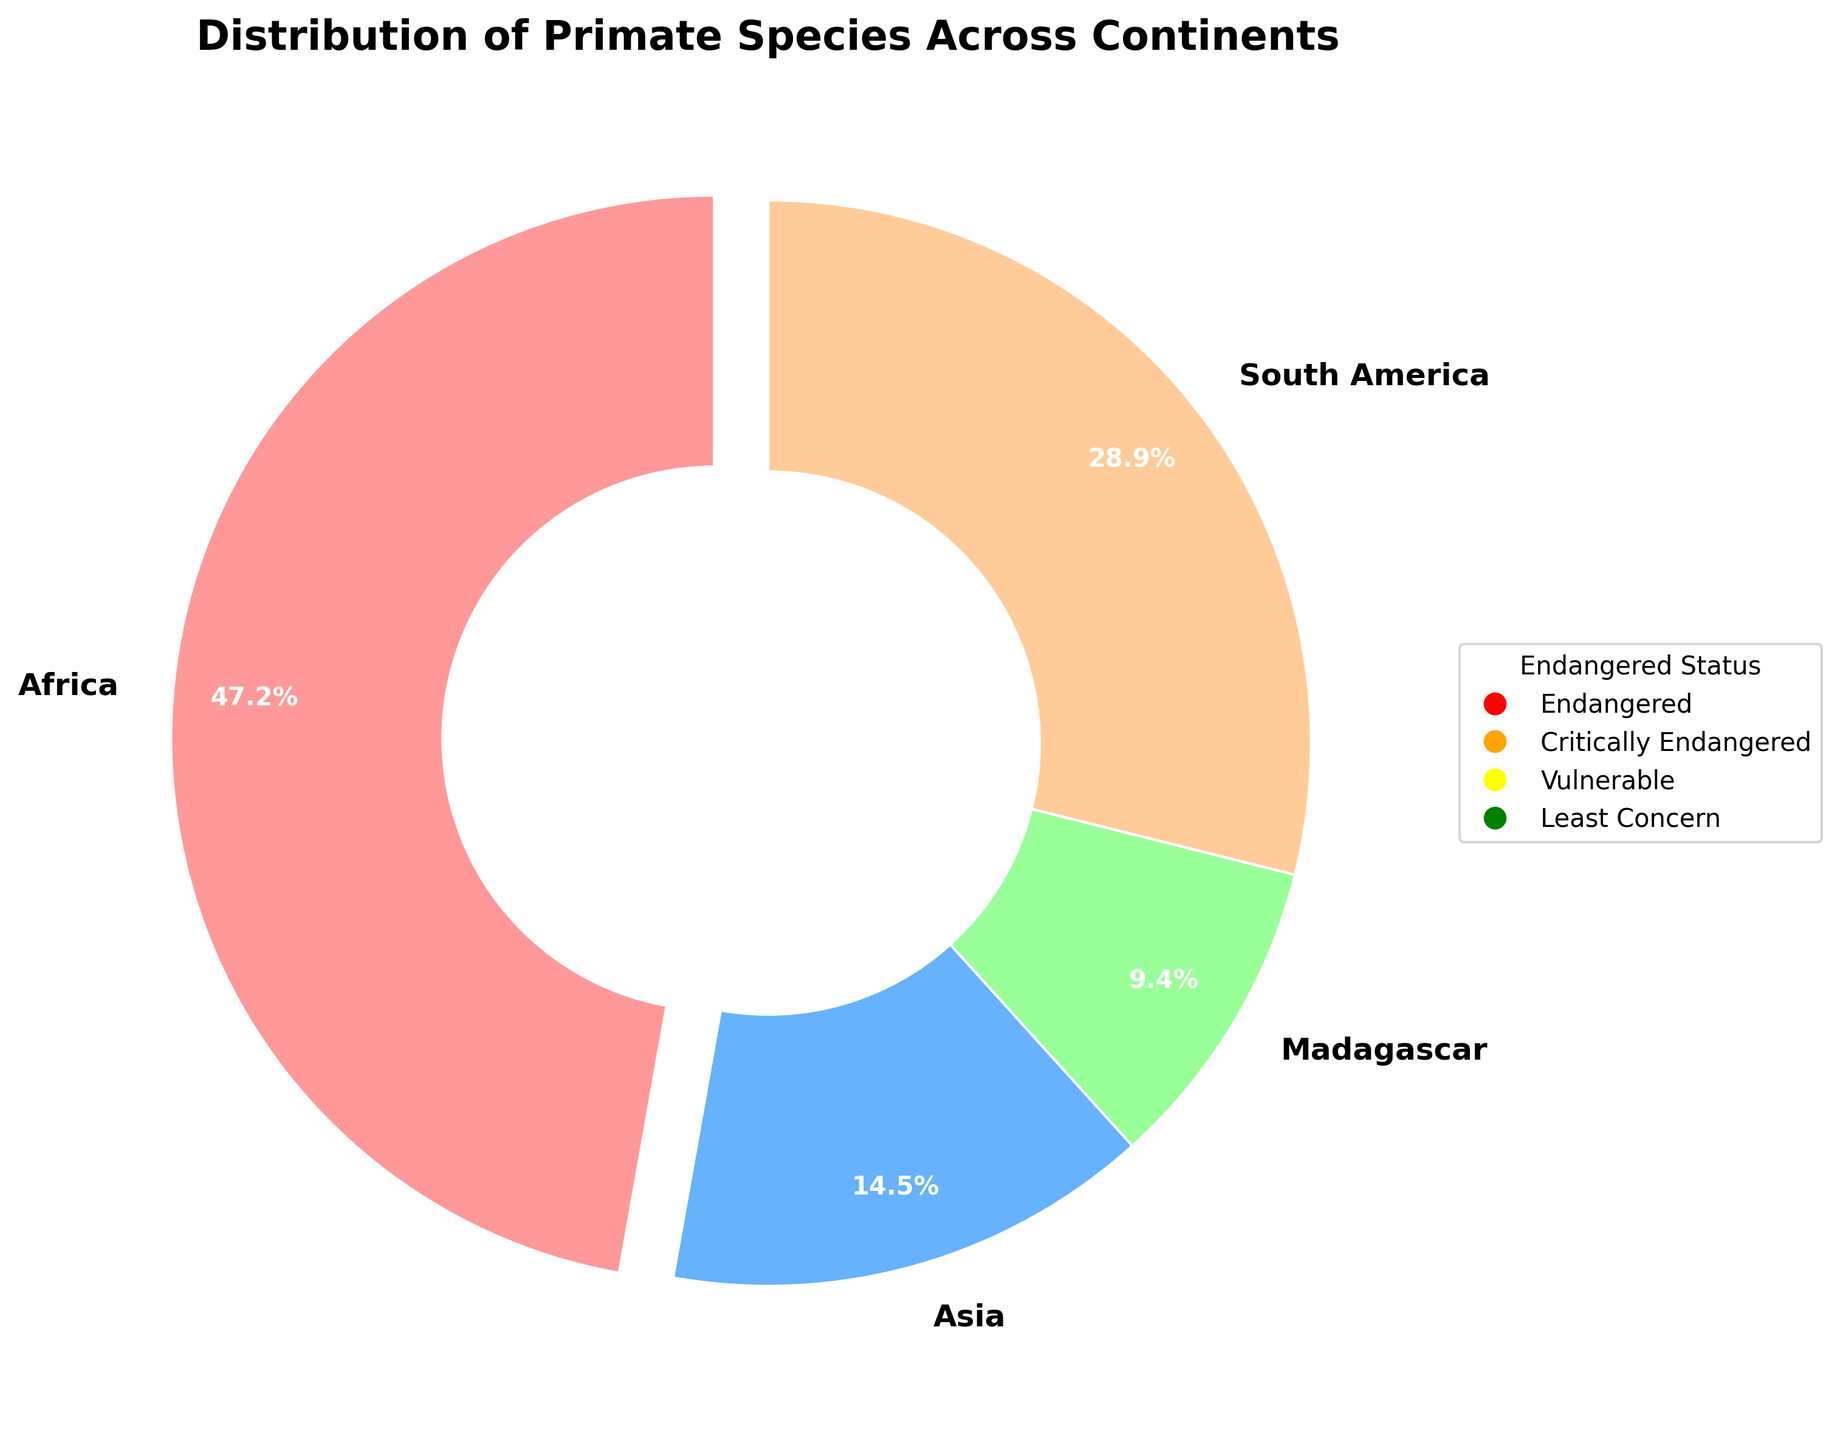Which continent has the highest percentage of primate species population? Step 1: Observe the pie chart labels and corresponding percentage values. Step 2: Identify the continent with the highest percentage.
Answer: Africa Which continent contains the lowest percentage of the primate species population? Step 1: Observe the pie chart labels and corresponding percentage values. Step 2: Identify the continent with the lowest percentage.
Answer: Madagascar What is the combined population percentage of primate species in Asia and South America? Step 1: Identify the individual percentages for Asia and South America from the pie chart. Step 2: Add these percentages together, Asia (14.5%) and South America (28.9%).
Answer: 43.4% Compare the population percentage of primate species in Africa and Madagascar. Which continent has a greater percentage, and by how much? Step 1: Identify the population percentages for Africa and Madagascar from the pie chart. Step 2: Calculate the difference, Africa (47.2%) and Madagascar (9.4%). Step 3: Determine which is greater and the difference (47.2% - 9.4%).
Answer: Africa by 37.8% What is the percentage difference in primate species population between the continents with the highest and lowest percentages? Step 1: Identify the highest and lowest population percentages from the pie chart. Step 2: Calculate the difference (47.2% - 9.4%).
Answer: 37.8% What percentage of the primate species population is found in continents other than Africa? Step 1: Identify the population percentage for Africa from the pie chart. Step 2: Subtract this percentage from 100% to get the population percentage for other continents (100% - 47.2%).
Answer: 52.8% Which color represents the continent of South America in the pie chart? Step 1: Observe the legend of the pie chart to correlate colors with continent names. South America is represented by green.
Answer: Green 